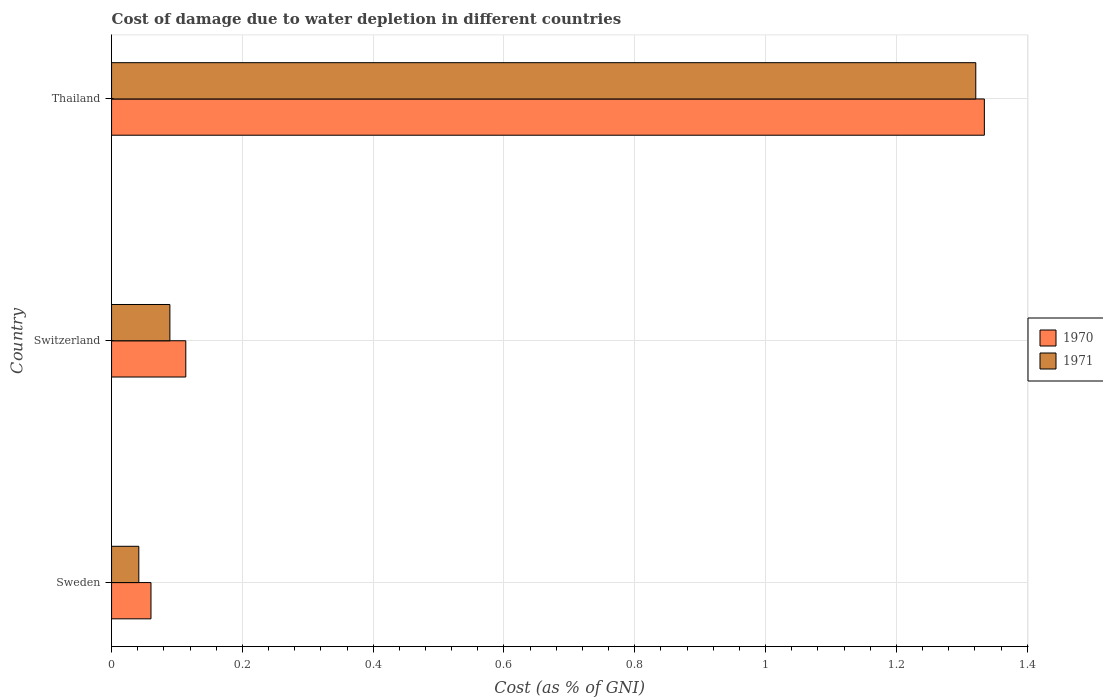How many bars are there on the 3rd tick from the top?
Keep it short and to the point. 2. What is the label of the 2nd group of bars from the top?
Ensure brevity in your answer.  Switzerland. What is the cost of damage caused due to water depletion in 1971 in Thailand?
Your answer should be very brief. 1.32. Across all countries, what is the maximum cost of damage caused due to water depletion in 1971?
Make the answer very short. 1.32. Across all countries, what is the minimum cost of damage caused due to water depletion in 1970?
Offer a terse response. 0.06. In which country was the cost of damage caused due to water depletion in 1970 maximum?
Keep it short and to the point. Thailand. In which country was the cost of damage caused due to water depletion in 1970 minimum?
Give a very brief answer. Sweden. What is the total cost of damage caused due to water depletion in 1970 in the graph?
Your answer should be compact. 1.51. What is the difference between the cost of damage caused due to water depletion in 1971 in Sweden and that in Thailand?
Offer a very short reply. -1.28. What is the difference between the cost of damage caused due to water depletion in 1970 in Switzerland and the cost of damage caused due to water depletion in 1971 in Thailand?
Give a very brief answer. -1.21. What is the average cost of damage caused due to water depletion in 1971 per country?
Provide a short and direct response. 0.48. What is the difference between the cost of damage caused due to water depletion in 1970 and cost of damage caused due to water depletion in 1971 in Switzerland?
Offer a very short reply. 0.02. What is the ratio of the cost of damage caused due to water depletion in 1971 in Sweden to that in Switzerland?
Provide a succinct answer. 0.47. Is the difference between the cost of damage caused due to water depletion in 1970 in Sweden and Switzerland greater than the difference between the cost of damage caused due to water depletion in 1971 in Sweden and Switzerland?
Keep it short and to the point. No. What is the difference between the highest and the second highest cost of damage caused due to water depletion in 1971?
Make the answer very short. 1.23. What is the difference between the highest and the lowest cost of damage caused due to water depletion in 1970?
Offer a terse response. 1.27. What does the 1st bar from the top in Sweden represents?
Ensure brevity in your answer.  1971. How many bars are there?
Give a very brief answer. 6. Are all the bars in the graph horizontal?
Your answer should be very brief. Yes. What is the difference between two consecutive major ticks on the X-axis?
Provide a succinct answer. 0.2. Are the values on the major ticks of X-axis written in scientific E-notation?
Your answer should be compact. No. Does the graph contain any zero values?
Provide a short and direct response. No. How are the legend labels stacked?
Give a very brief answer. Vertical. What is the title of the graph?
Give a very brief answer. Cost of damage due to water depletion in different countries. Does "1975" appear as one of the legend labels in the graph?
Give a very brief answer. No. What is the label or title of the X-axis?
Offer a very short reply. Cost (as % of GNI). What is the Cost (as % of GNI) of 1970 in Sweden?
Your answer should be very brief. 0.06. What is the Cost (as % of GNI) of 1971 in Sweden?
Provide a short and direct response. 0.04. What is the Cost (as % of GNI) of 1970 in Switzerland?
Keep it short and to the point. 0.11. What is the Cost (as % of GNI) in 1971 in Switzerland?
Offer a very short reply. 0.09. What is the Cost (as % of GNI) of 1970 in Thailand?
Make the answer very short. 1.33. What is the Cost (as % of GNI) in 1971 in Thailand?
Make the answer very short. 1.32. Across all countries, what is the maximum Cost (as % of GNI) of 1970?
Your answer should be very brief. 1.33. Across all countries, what is the maximum Cost (as % of GNI) of 1971?
Give a very brief answer. 1.32. Across all countries, what is the minimum Cost (as % of GNI) of 1970?
Offer a very short reply. 0.06. Across all countries, what is the minimum Cost (as % of GNI) of 1971?
Provide a succinct answer. 0.04. What is the total Cost (as % of GNI) of 1970 in the graph?
Provide a succinct answer. 1.51. What is the total Cost (as % of GNI) of 1971 in the graph?
Your response must be concise. 1.45. What is the difference between the Cost (as % of GNI) in 1970 in Sweden and that in Switzerland?
Offer a terse response. -0.05. What is the difference between the Cost (as % of GNI) in 1971 in Sweden and that in Switzerland?
Your answer should be compact. -0.05. What is the difference between the Cost (as % of GNI) in 1970 in Sweden and that in Thailand?
Provide a short and direct response. -1.27. What is the difference between the Cost (as % of GNI) of 1971 in Sweden and that in Thailand?
Provide a succinct answer. -1.28. What is the difference between the Cost (as % of GNI) in 1970 in Switzerland and that in Thailand?
Your answer should be very brief. -1.22. What is the difference between the Cost (as % of GNI) in 1971 in Switzerland and that in Thailand?
Make the answer very short. -1.23. What is the difference between the Cost (as % of GNI) in 1970 in Sweden and the Cost (as % of GNI) in 1971 in Switzerland?
Provide a succinct answer. -0.03. What is the difference between the Cost (as % of GNI) of 1970 in Sweden and the Cost (as % of GNI) of 1971 in Thailand?
Give a very brief answer. -1.26. What is the difference between the Cost (as % of GNI) in 1970 in Switzerland and the Cost (as % of GNI) in 1971 in Thailand?
Provide a short and direct response. -1.21. What is the average Cost (as % of GNI) in 1970 per country?
Give a very brief answer. 0.5. What is the average Cost (as % of GNI) in 1971 per country?
Give a very brief answer. 0.48. What is the difference between the Cost (as % of GNI) in 1970 and Cost (as % of GNI) in 1971 in Sweden?
Provide a succinct answer. 0.02. What is the difference between the Cost (as % of GNI) of 1970 and Cost (as % of GNI) of 1971 in Switzerland?
Offer a very short reply. 0.02. What is the difference between the Cost (as % of GNI) in 1970 and Cost (as % of GNI) in 1971 in Thailand?
Make the answer very short. 0.01. What is the ratio of the Cost (as % of GNI) of 1970 in Sweden to that in Switzerland?
Keep it short and to the point. 0.53. What is the ratio of the Cost (as % of GNI) of 1971 in Sweden to that in Switzerland?
Keep it short and to the point. 0.47. What is the ratio of the Cost (as % of GNI) in 1970 in Sweden to that in Thailand?
Provide a short and direct response. 0.05. What is the ratio of the Cost (as % of GNI) of 1971 in Sweden to that in Thailand?
Keep it short and to the point. 0.03. What is the ratio of the Cost (as % of GNI) in 1970 in Switzerland to that in Thailand?
Keep it short and to the point. 0.09. What is the ratio of the Cost (as % of GNI) of 1971 in Switzerland to that in Thailand?
Offer a terse response. 0.07. What is the difference between the highest and the second highest Cost (as % of GNI) of 1970?
Provide a succinct answer. 1.22. What is the difference between the highest and the second highest Cost (as % of GNI) in 1971?
Your answer should be very brief. 1.23. What is the difference between the highest and the lowest Cost (as % of GNI) in 1970?
Provide a succinct answer. 1.27. What is the difference between the highest and the lowest Cost (as % of GNI) of 1971?
Your answer should be very brief. 1.28. 